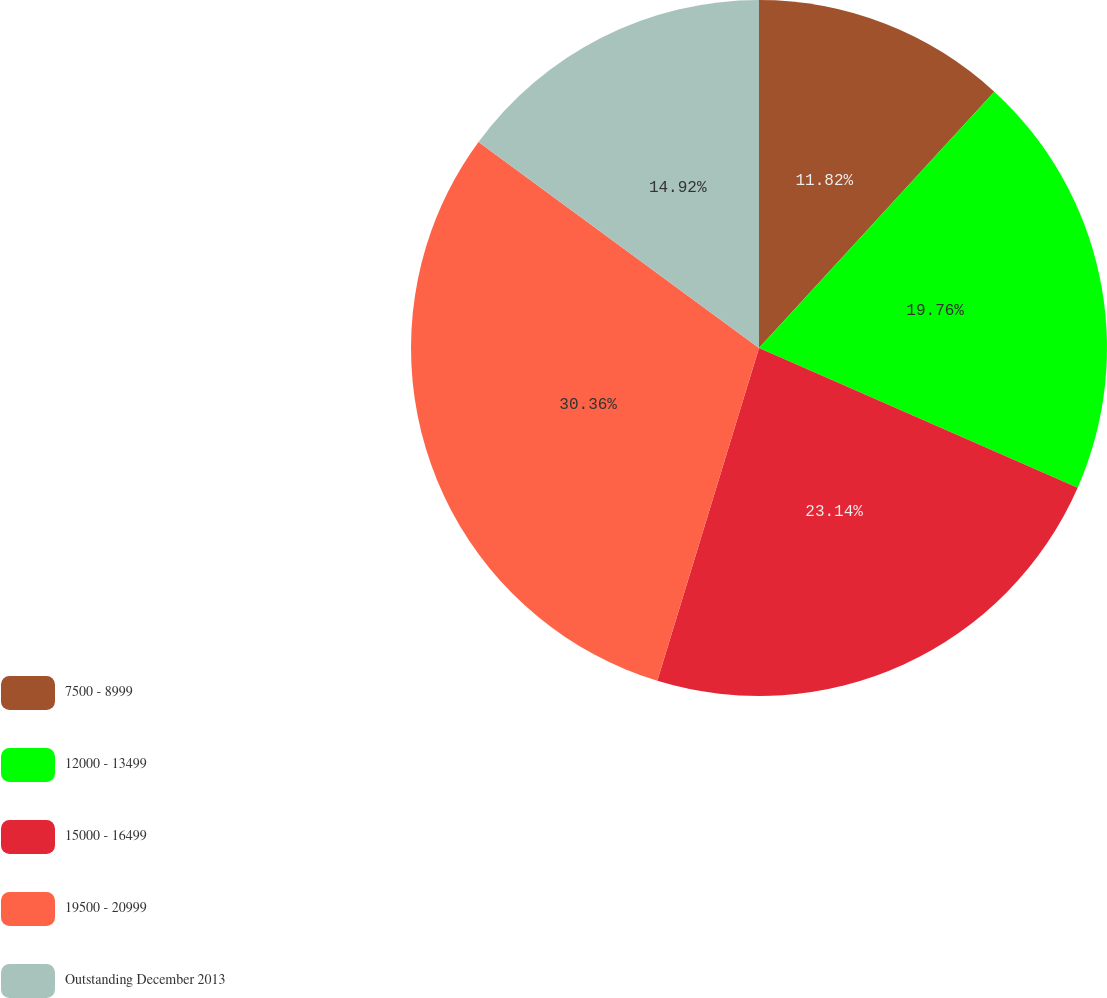Convert chart. <chart><loc_0><loc_0><loc_500><loc_500><pie_chart><fcel>7500 - 8999<fcel>12000 - 13499<fcel>15000 - 16499<fcel>19500 - 20999<fcel>Outstanding December 2013<nl><fcel>11.82%<fcel>19.76%<fcel>23.14%<fcel>30.36%<fcel>14.92%<nl></chart> 